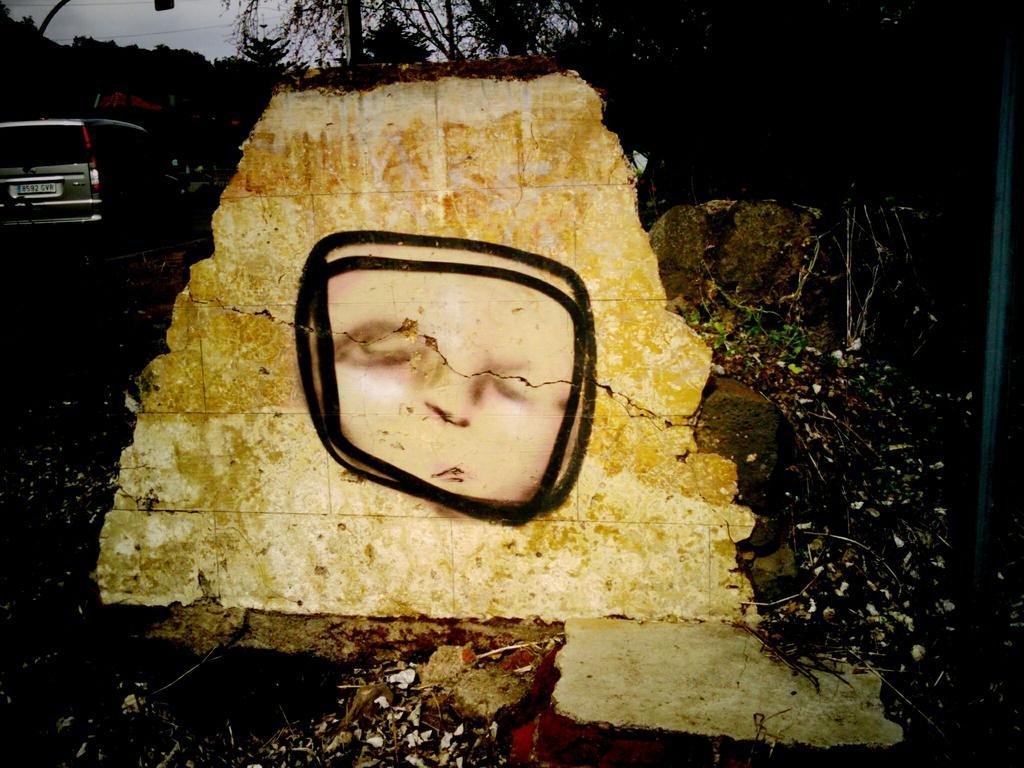Can you describe this image briefly? In the center of the image there is a wall. On the wall, we can see some painting, in which we can see a human face in the black border. In the background, we can see the sky, clouds, trees, one car and a few other objects. 